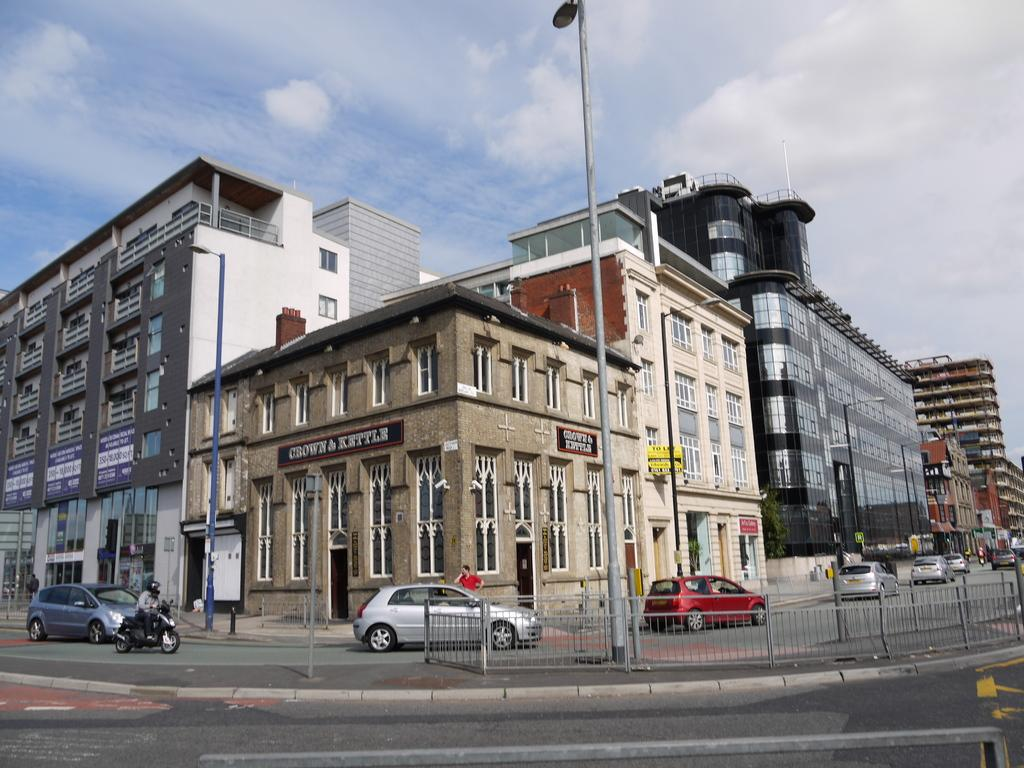What is located at the bottom of the image? There is a road at the bottom of the image. What is visible at the top of the image? There is sky at the top of the image. What type of structures can be seen in the image? There are buildings in the image. Who or what is present in the image? There are people in the image. What else can be seen moving in the image? There are vehicles in the image. What objects are present to provide illumination? There are poles with lights in the image. Where is the tent located in the image? There is no tent present in the image. What type of swing can be seen in the image? There is no swing present in the image. 